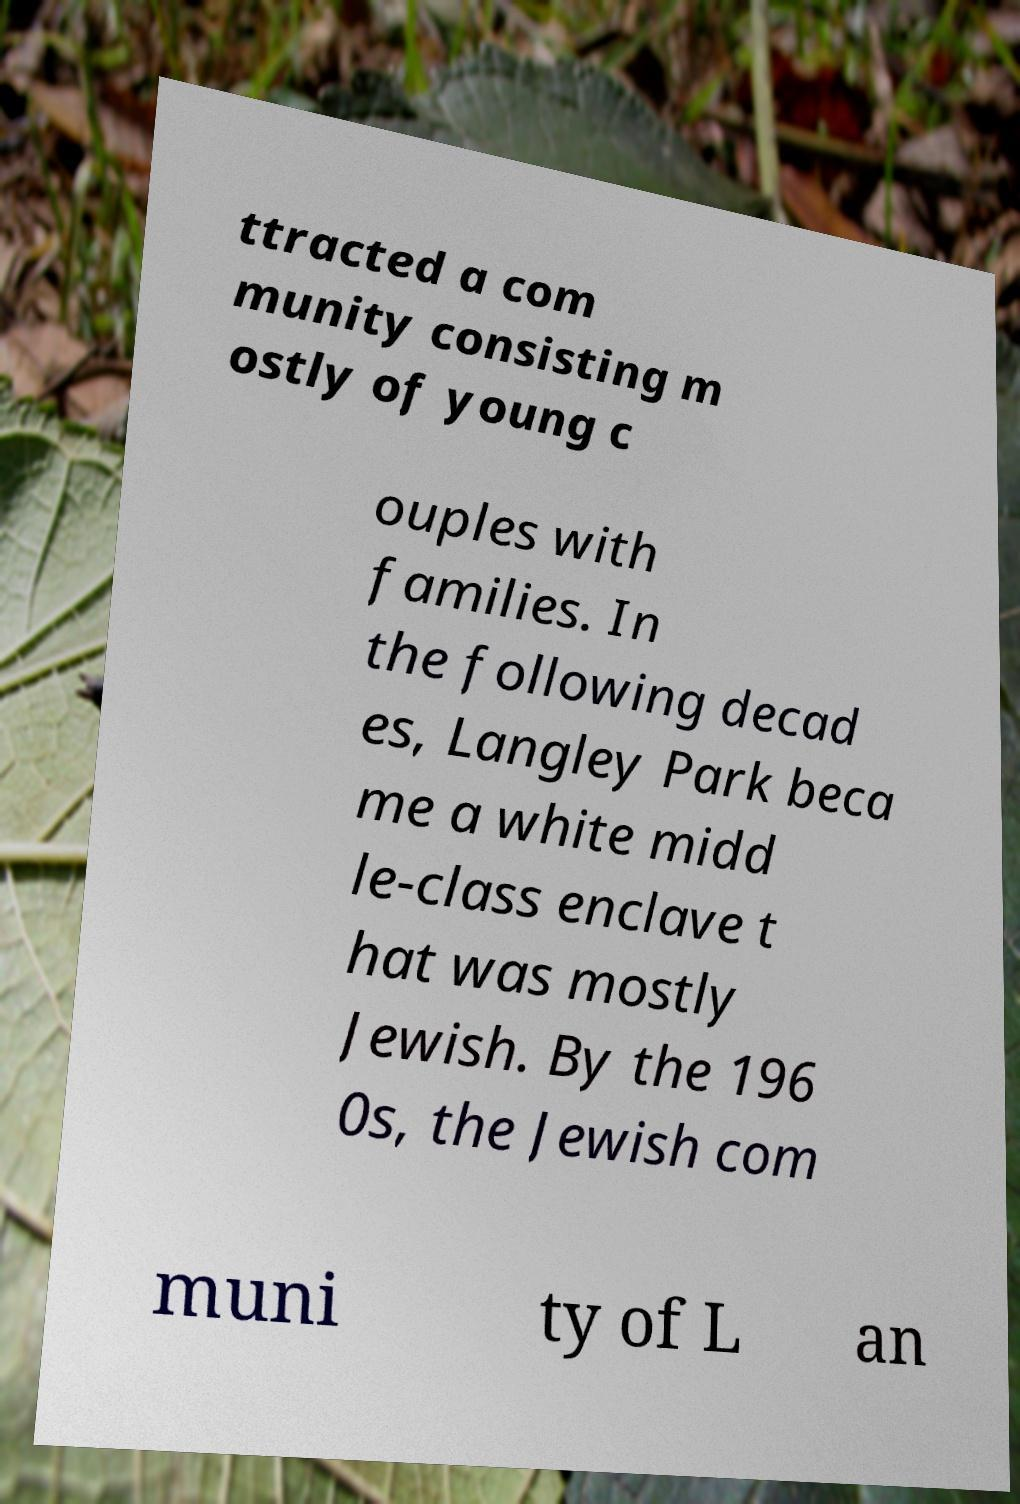What messages or text are displayed in this image? I need them in a readable, typed format. ttracted a com munity consisting m ostly of young c ouples with families. In the following decad es, Langley Park beca me a white midd le-class enclave t hat was mostly Jewish. By the 196 0s, the Jewish com muni ty of L an 